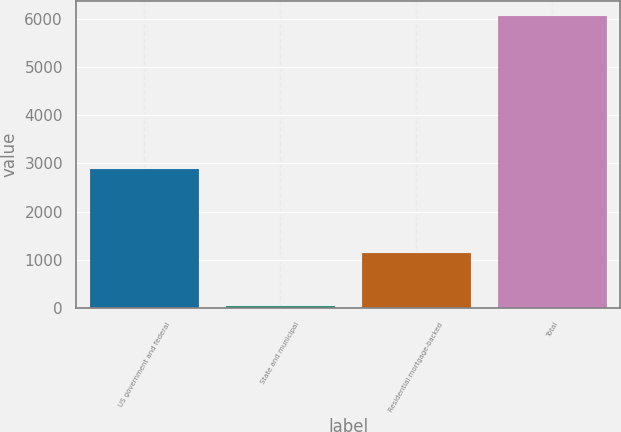<chart> <loc_0><loc_0><loc_500><loc_500><bar_chart><fcel>US government and federal<fcel>State and municipal<fcel>Residential mortgage-backed<fcel>Total<nl><fcel>2888<fcel>48<fcel>1139<fcel>6062<nl></chart> 